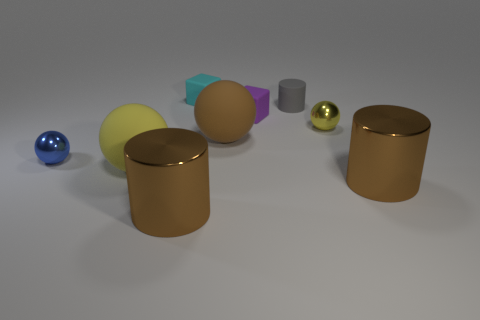Subtract all cylinders. How many objects are left? 6 Add 7 tiny gray objects. How many tiny gray objects are left? 8 Add 1 metal cylinders. How many metal cylinders exist? 3 Subtract 0 brown blocks. How many objects are left? 9 Subtract all cyan matte objects. Subtract all cyan rubber cubes. How many objects are left? 7 